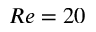<formula> <loc_0><loc_0><loc_500><loc_500>R e = 2 0</formula> 